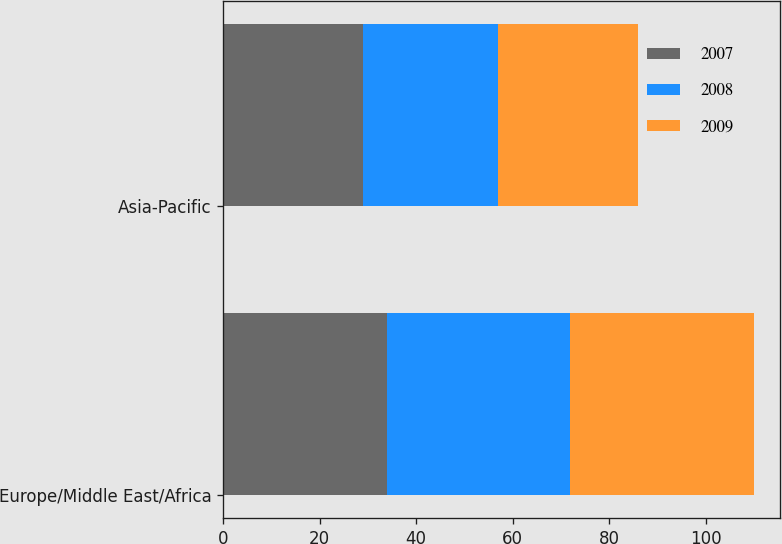Convert chart. <chart><loc_0><loc_0><loc_500><loc_500><stacked_bar_chart><ecel><fcel>Europe/Middle East/Africa<fcel>Asia-Pacific<nl><fcel>2007<fcel>34<fcel>29<nl><fcel>2008<fcel>38<fcel>28<nl><fcel>2009<fcel>38<fcel>29<nl></chart> 